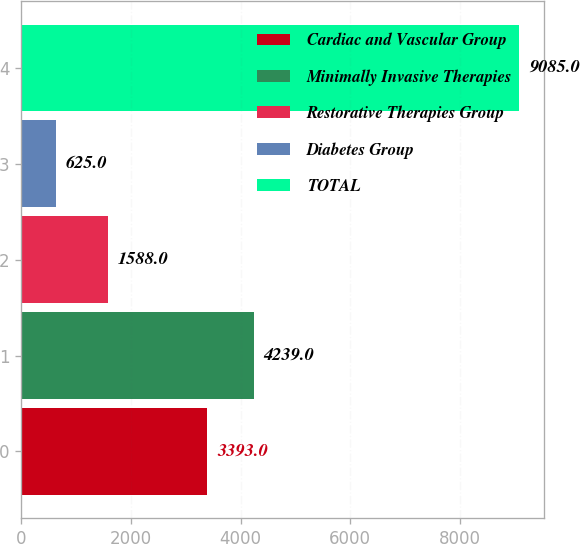Convert chart. <chart><loc_0><loc_0><loc_500><loc_500><bar_chart><fcel>Cardiac and Vascular Group<fcel>Minimally Invasive Therapies<fcel>Restorative Therapies Group<fcel>Diabetes Group<fcel>TOTAL<nl><fcel>3393<fcel>4239<fcel>1588<fcel>625<fcel>9085<nl></chart> 